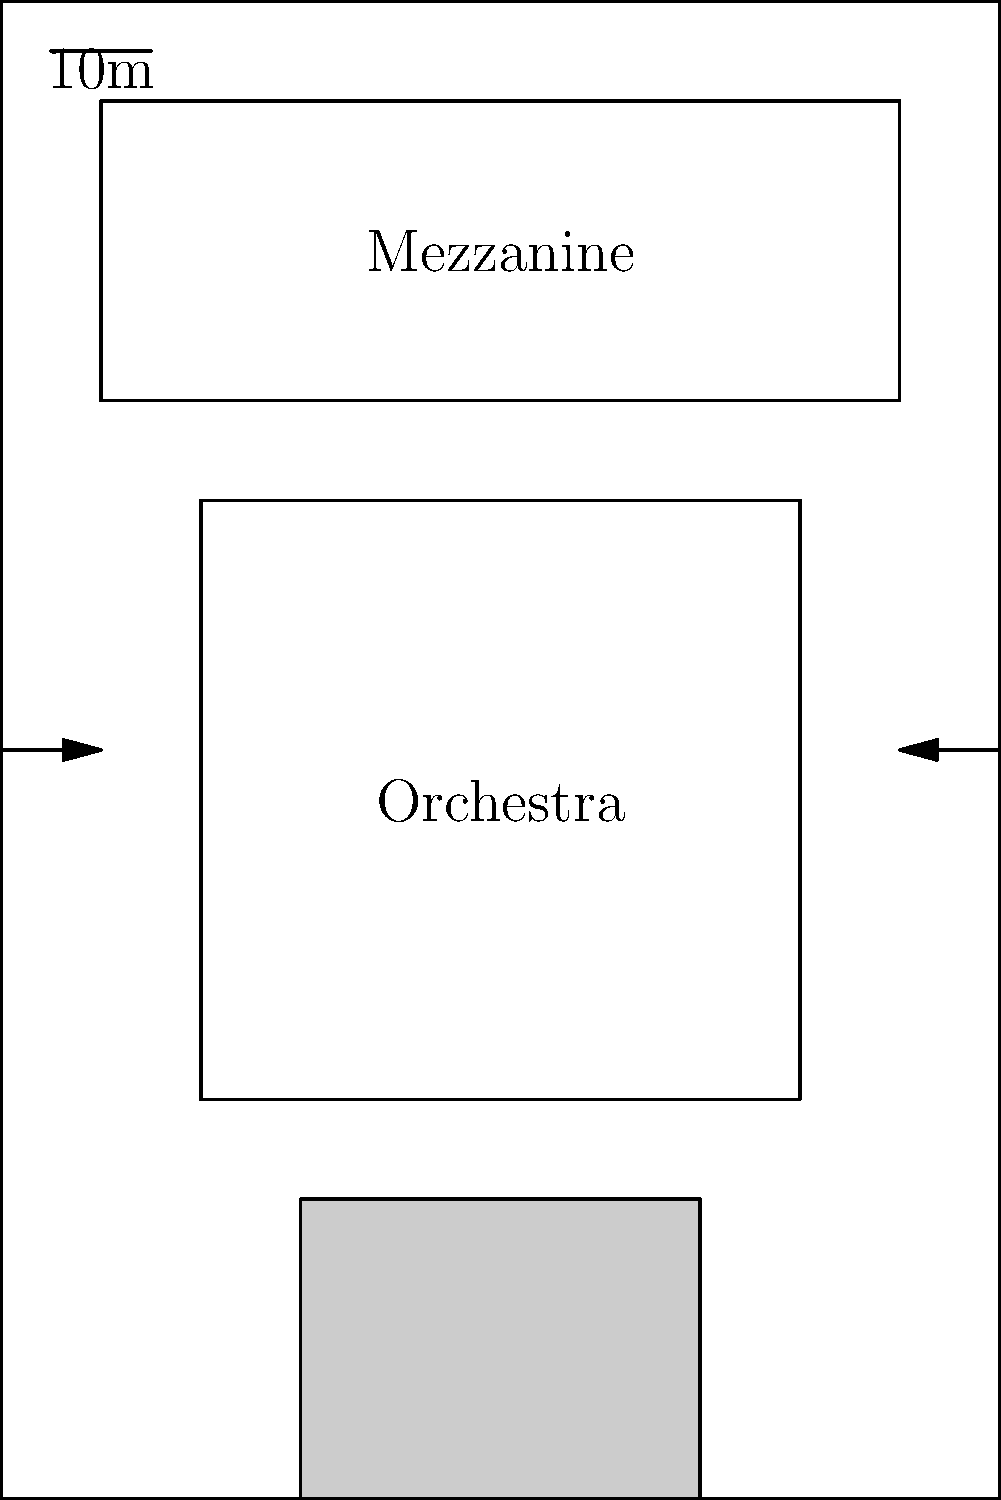Examine the overhead floor plan of this concert hall. Which famous venue does this layout most closely resemble, known for its exceptional acoustics and horseshoe-shaped auditorium? To identify this concert hall, let's analyze its key features:

1. Overall shape: The hall has a rectangular layout, which is common in many concert venues.

2. Stage placement: The stage is located at one end of the hall, typical for traditional concert halls.

3. Seating arrangement: 
   a. The main seating area (labeled "Orchestra") is relatively wide and extends from near the stage to about 2/3 of the hall's length.
   b. There's a second seating area (labeled "Mezzanine") at the rear of the hall, which is narrower than the orchestra section.

4. Entrances: There are side entrances on both sides of the hall.

5. Proportions: The hall is longer than it is wide, with the stage taking up about 1/5 of the total length.

These features, especially the wide orchestra section and the narrower mezzanine at the rear, are characteristic of a horseshoe-shaped auditorium when viewed from above. This layout is famous for its excellent acoustics.

One of the most renowned concert halls with this type of layout is La Scala in Milan, Italy. La Scala is known worldwide for its exceptional acoustics and its horseshoe-shaped auditorium, which this floor plan closely resembles.

While other famous venues like the Vienna State Opera House also have horseshoe shapes, La Scala is particularly noted for its wide orchestra section and narrower upper levels, which match this floor plan.
Answer: La Scala, Milan 